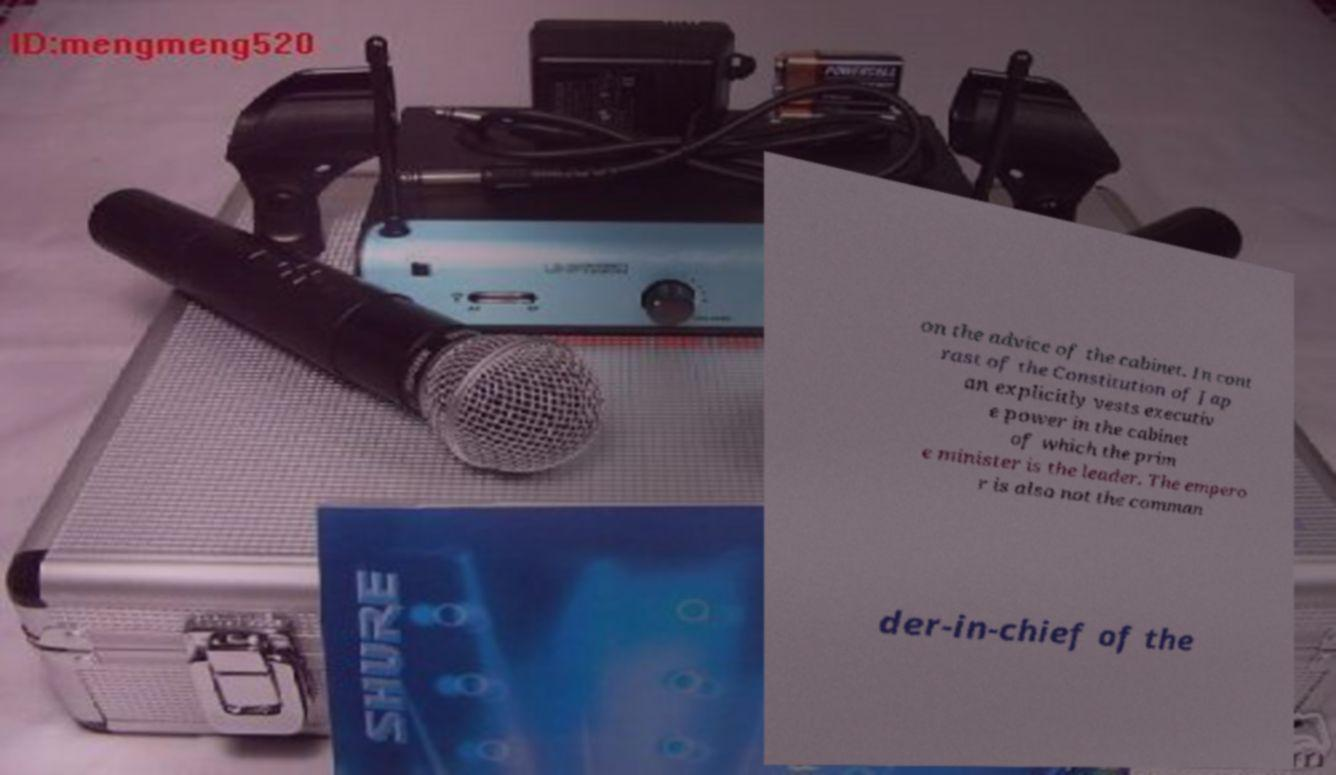Please identify and transcribe the text found in this image. on the advice of the cabinet. In cont rast of the Constitution of Jap an explicitly vests executiv e power in the cabinet of which the prim e minister is the leader. The empero r is also not the comman der-in-chief of the 